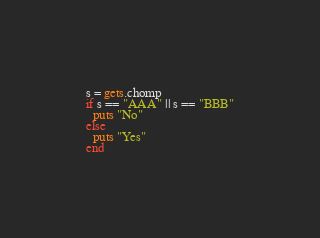<code> <loc_0><loc_0><loc_500><loc_500><_Ruby_>s = gets.chomp
if s == "AAA" || s == "BBB"
  puts "No"
else
  puts "Yes"
end</code> 